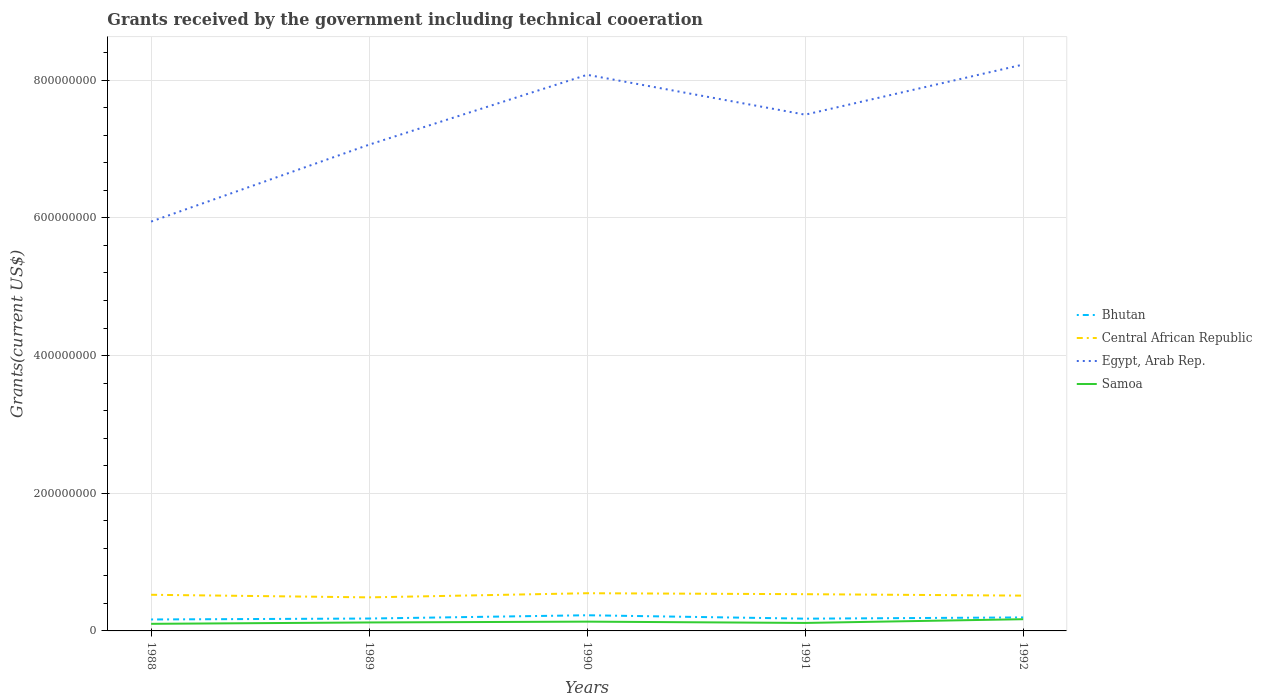How many different coloured lines are there?
Provide a succinct answer. 4. Does the line corresponding to Samoa intersect with the line corresponding to Egypt, Arab Rep.?
Offer a terse response. No. Across all years, what is the maximum total grants received by the government in Central African Republic?
Your answer should be compact. 4.87e+07. What is the total total grants received by the government in Central African Republic in the graph?
Your answer should be very brief. 1.23e+06. What is the difference between the highest and the second highest total grants received by the government in Samoa?
Your answer should be compact. 6.71e+06. What is the difference between the highest and the lowest total grants received by the government in Central African Republic?
Your answer should be compact. 3. Is the total grants received by the government in Bhutan strictly greater than the total grants received by the government in Samoa over the years?
Offer a terse response. No. How many lines are there?
Give a very brief answer. 4. Are the values on the major ticks of Y-axis written in scientific E-notation?
Your answer should be compact. No. Does the graph contain grids?
Ensure brevity in your answer.  Yes. What is the title of the graph?
Ensure brevity in your answer.  Grants received by the government including technical cooeration. Does "Nigeria" appear as one of the legend labels in the graph?
Make the answer very short. No. What is the label or title of the X-axis?
Ensure brevity in your answer.  Years. What is the label or title of the Y-axis?
Offer a very short reply. Grants(current US$). What is the Grants(current US$) in Bhutan in 1988?
Give a very brief answer. 1.66e+07. What is the Grants(current US$) in Central African Republic in 1988?
Give a very brief answer. 5.25e+07. What is the Grants(current US$) in Egypt, Arab Rep. in 1988?
Offer a very short reply. 5.95e+08. What is the Grants(current US$) in Samoa in 1988?
Ensure brevity in your answer.  1.03e+07. What is the Grants(current US$) of Bhutan in 1989?
Offer a terse response. 1.80e+07. What is the Grants(current US$) of Central African Republic in 1989?
Provide a succinct answer. 4.87e+07. What is the Grants(current US$) of Egypt, Arab Rep. in 1989?
Offer a very short reply. 7.06e+08. What is the Grants(current US$) in Samoa in 1989?
Your response must be concise. 1.23e+07. What is the Grants(current US$) in Bhutan in 1990?
Provide a short and direct response. 2.28e+07. What is the Grants(current US$) in Central African Republic in 1990?
Provide a succinct answer. 5.48e+07. What is the Grants(current US$) in Egypt, Arab Rep. in 1990?
Offer a terse response. 8.08e+08. What is the Grants(current US$) in Samoa in 1990?
Ensure brevity in your answer.  1.35e+07. What is the Grants(current US$) of Bhutan in 1991?
Give a very brief answer. 1.78e+07. What is the Grants(current US$) of Central African Republic in 1991?
Your response must be concise. 5.34e+07. What is the Grants(current US$) in Egypt, Arab Rep. in 1991?
Keep it short and to the point. 7.50e+08. What is the Grants(current US$) in Samoa in 1991?
Your response must be concise. 1.16e+07. What is the Grants(current US$) in Bhutan in 1992?
Your response must be concise. 1.96e+07. What is the Grants(current US$) in Central African Republic in 1992?
Your answer should be compact. 5.13e+07. What is the Grants(current US$) in Egypt, Arab Rep. in 1992?
Ensure brevity in your answer.  8.23e+08. What is the Grants(current US$) in Samoa in 1992?
Keep it short and to the point. 1.70e+07. Across all years, what is the maximum Grants(current US$) of Bhutan?
Give a very brief answer. 2.28e+07. Across all years, what is the maximum Grants(current US$) of Central African Republic?
Offer a very short reply. 5.48e+07. Across all years, what is the maximum Grants(current US$) in Egypt, Arab Rep.?
Make the answer very short. 8.23e+08. Across all years, what is the maximum Grants(current US$) of Samoa?
Provide a short and direct response. 1.70e+07. Across all years, what is the minimum Grants(current US$) in Bhutan?
Offer a terse response. 1.66e+07. Across all years, what is the minimum Grants(current US$) of Central African Republic?
Provide a succinct answer. 4.87e+07. Across all years, what is the minimum Grants(current US$) of Egypt, Arab Rep.?
Your answer should be very brief. 5.95e+08. Across all years, what is the minimum Grants(current US$) of Samoa?
Make the answer very short. 1.03e+07. What is the total Grants(current US$) of Bhutan in the graph?
Ensure brevity in your answer.  9.48e+07. What is the total Grants(current US$) in Central African Republic in the graph?
Your response must be concise. 2.61e+08. What is the total Grants(current US$) of Egypt, Arab Rep. in the graph?
Your answer should be compact. 3.68e+09. What is the total Grants(current US$) in Samoa in the graph?
Offer a very short reply. 6.47e+07. What is the difference between the Grants(current US$) of Bhutan in 1988 and that in 1989?
Your answer should be very brief. -1.36e+06. What is the difference between the Grants(current US$) in Central African Republic in 1988 and that in 1989?
Provide a succinct answer. 3.76e+06. What is the difference between the Grants(current US$) in Egypt, Arab Rep. in 1988 and that in 1989?
Keep it short and to the point. -1.12e+08. What is the difference between the Grants(current US$) of Samoa in 1988 and that in 1989?
Your response must be concise. -2.01e+06. What is the difference between the Grants(current US$) in Bhutan in 1988 and that in 1990?
Your answer should be compact. -6.13e+06. What is the difference between the Grants(current US$) in Central African Republic in 1988 and that in 1990?
Provide a short and direct response. -2.26e+06. What is the difference between the Grants(current US$) in Egypt, Arab Rep. in 1988 and that in 1990?
Provide a succinct answer. -2.13e+08. What is the difference between the Grants(current US$) of Samoa in 1988 and that in 1990?
Offer a terse response. -3.17e+06. What is the difference between the Grants(current US$) in Bhutan in 1988 and that in 1991?
Your answer should be compact. -1.16e+06. What is the difference between the Grants(current US$) in Central African Republic in 1988 and that in 1991?
Provide a short and direct response. -8.60e+05. What is the difference between the Grants(current US$) of Egypt, Arab Rep. in 1988 and that in 1991?
Your answer should be very brief. -1.55e+08. What is the difference between the Grants(current US$) of Samoa in 1988 and that in 1991?
Keep it short and to the point. -1.30e+06. What is the difference between the Grants(current US$) of Bhutan in 1988 and that in 1992?
Offer a very short reply. -2.97e+06. What is the difference between the Grants(current US$) of Central African Republic in 1988 and that in 1992?
Ensure brevity in your answer.  1.23e+06. What is the difference between the Grants(current US$) in Egypt, Arab Rep. in 1988 and that in 1992?
Make the answer very short. -2.28e+08. What is the difference between the Grants(current US$) in Samoa in 1988 and that in 1992?
Your answer should be very brief. -6.71e+06. What is the difference between the Grants(current US$) of Bhutan in 1989 and that in 1990?
Offer a very short reply. -4.77e+06. What is the difference between the Grants(current US$) in Central African Republic in 1989 and that in 1990?
Give a very brief answer. -6.02e+06. What is the difference between the Grants(current US$) in Egypt, Arab Rep. in 1989 and that in 1990?
Ensure brevity in your answer.  -1.02e+08. What is the difference between the Grants(current US$) in Samoa in 1989 and that in 1990?
Your answer should be very brief. -1.16e+06. What is the difference between the Grants(current US$) of Central African Republic in 1989 and that in 1991?
Give a very brief answer. -4.62e+06. What is the difference between the Grants(current US$) in Egypt, Arab Rep. in 1989 and that in 1991?
Provide a short and direct response. -4.36e+07. What is the difference between the Grants(current US$) of Samoa in 1989 and that in 1991?
Keep it short and to the point. 7.10e+05. What is the difference between the Grants(current US$) in Bhutan in 1989 and that in 1992?
Offer a terse response. -1.61e+06. What is the difference between the Grants(current US$) in Central African Republic in 1989 and that in 1992?
Make the answer very short. -2.53e+06. What is the difference between the Grants(current US$) in Egypt, Arab Rep. in 1989 and that in 1992?
Your answer should be compact. -1.16e+08. What is the difference between the Grants(current US$) of Samoa in 1989 and that in 1992?
Keep it short and to the point. -4.70e+06. What is the difference between the Grants(current US$) in Bhutan in 1990 and that in 1991?
Keep it short and to the point. 4.97e+06. What is the difference between the Grants(current US$) in Central African Republic in 1990 and that in 1991?
Your response must be concise. 1.40e+06. What is the difference between the Grants(current US$) in Egypt, Arab Rep. in 1990 and that in 1991?
Offer a very short reply. 5.79e+07. What is the difference between the Grants(current US$) of Samoa in 1990 and that in 1991?
Provide a succinct answer. 1.87e+06. What is the difference between the Grants(current US$) of Bhutan in 1990 and that in 1992?
Offer a terse response. 3.16e+06. What is the difference between the Grants(current US$) in Central African Republic in 1990 and that in 1992?
Your response must be concise. 3.49e+06. What is the difference between the Grants(current US$) in Egypt, Arab Rep. in 1990 and that in 1992?
Your answer should be compact. -1.49e+07. What is the difference between the Grants(current US$) of Samoa in 1990 and that in 1992?
Provide a succinct answer. -3.54e+06. What is the difference between the Grants(current US$) in Bhutan in 1991 and that in 1992?
Make the answer very short. -1.81e+06. What is the difference between the Grants(current US$) in Central African Republic in 1991 and that in 1992?
Provide a short and direct response. 2.09e+06. What is the difference between the Grants(current US$) of Egypt, Arab Rep. in 1991 and that in 1992?
Offer a very short reply. -7.28e+07. What is the difference between the Grants(current US$) in Samoa in 1991 and that in 1992?
Offer a terse response. -5.41e+06. What is the difference between the Grants(current US$) in Bhutan in 1988 and the Grants(current US$) in Central African Republic in 1989?
Your answer should be very brief. -3.21e+07. What is the difference between the Grants(current US$) of Bhutan in 1988 and the Grants(current US$) of Egypt, Arab Rep. in 1989?
Make the answer very short. -6.90e+08. What is the difference between the Grants(current US$) of Bhutan in 1988 and the Grants(current US$) of Samoa in 1989?
Ensure brevity in your answer.  4.33e+06. What is the difference between the Grants(current US$) of Central African Republic in 1988 and the Grants(current US$) of Egypt, Arab Rep. in 1989?
Provide a succinct answer. -6.54e+08. What is the difference between the Grants(current US$) of Central African Republic in 1988 and the Grants(current US$) of Samoa in 1989?
Make the answer very short. 4.02e+07. What is the difference between the Grants(current US$) of Egypt, Arab Rep. in 1988 and the Grants(current US$) of Samoa in 1989?
Your answer should be compact. 5.82e+08. What is the difference between the Grants(current US$) of Bhutan in 1988 and the Grants(current US$) of Central African Republic in 1990?
Offer a terse response. -3.81e+07. What is the difference between the Grants(current US$) of Bhutan in 1988 and the Grants(current US$) of Egypt, Arab Rep. in 1990?
Offer a very short reply. -7.91e+08. What is the difference between the Grants(current US$) of Bhutan in 1988 and the Grants(current US$) of Samoa in 1990?
Give a very brief answer. 3.17e+06. What is the difference between the Grants(current US$) in Central African Republic in 1988 and the Grants(current US$) in Egypt, Arab Rep. in 1990?
Ensure brevity in your answer.  -7.55e+08. What is the difference between the Grants(current US$) of Central African Republic in 1988 and the Grants(current US$) of Samoa in 1990?
Ensure brevity in your answer.  3.90e+07. What is the difference between the Grants(current US$) in Egypt, Arab Rep. in 1988 and the Grants(current US$) in Samoa in 1990?
Provide a succinct answer. 5.81e+08. What is the difference between the Grants(current US$) of Bhutan in 1988 and the Grants(current US$) of Central African Republic in 1991?
Your answer should be very brief. -3.67e+07. What is the difference between the Grants(current US$) in Bhutan in 1988 and the Grants(current US$) in Egypt, Arab Rep. in 1991?
Provide a short and direct response. -7.33e+08. What is the difference between the Grants(current US$) of Bhutan in 1988 and the Grants(current US$) of Samoa in 1991?
Ensure brevity in your answer.  5.04e+06. What is the difference between the Grants(current US$) in Central African Republic in 1988 and the Grants(current US$) in Egypt, Arab Rep. in 1991?
Your answer should be compact. -6.97e+08. What is the difference between the Grants(current US$) in Central African Republic in 1988 and the Grants(current US$) in Samoa in 1991?
Provide a succinct answer. 4.09e+07. What is the difference between the Grants(current US$) of Egypt, Arab Rep. in 1988 and the Grants(current US$) of Samoa in 1991?
Your response must be concise. 5.83e+08. What is the difference between the Grants(current US$) of Bhutan in 1988 and the Grants(current US$) of Central African Republic in 1992?
Your answer should be compact. -3.46e+07. What is the difference between the Grants(current US$) of Bhutan in 1988 and the Grants(current US$) of Egypt, Arab Rep. in 1992?
Ensure brevity in your answer.  -8.06e+08. What is the difference between the Grants(current US$) of Bhutan in 1988 and the Grants(current US$) of Samoa in 1992?
Offer a terse response. -3.70e+05. What is the difference between the Grants(current US$) of Central African Republic in 1988 and the Grants(current US$) of Egypt, Arab Rep. in 1992?
Ensure brevity in your answer.  -7.70e+08. What is the difference between the Grants(current US$) of Central African Republic in 1988 and the Grants(current US$) of Samoa in 1992?
Offer a very short reply. 3.55e+07. What is the difference between the Grants(current US$) in Egypt, Arab Rep. in 1988 and the Grants(current US$) in Samoa in 1992?
Your response must be concise. 5.78e+08. What is the difference between the Grants(current US$) of Bhutan in 1989 and the Grants(current US$) of Central African Republic in 1990?
Provide a short and direct response. -3.68e+07. What is the difference between the Grants(current US$) of Bhutan in 1989 and the Grants(current US$) of Egypt, Arab Rep. in 1990?
Provide a short and direct response. -7.90e+08. What is the difference between the Grants(current US$) of Bhutan in 1989 and the Grants(current US$) of Samoa in 1990?
Ensure brevity in your answer.  4.53e+06. What is the difference between the Grants(current US$) in Central African Republic in 1989 and the Grants(current US$) in Egypt, Arab Rep. in 1990?
Give a very brief answer. -7.59e+08. What is the difference between the Grants(current US$) of Central African Republic in 1989 and the Grants(current US$) of Samoa in 1990?
Your answer should be very brief. 3.53e+07. What is the difference between the Grants(current US$) of Egypt, Arab Rep. in 1989 and the Grants(current US$) of Samoa in 1990?
Make the answer very short. 6.93e+08. What is the difference between the Grants(current US$) in Bhutan in 1989 and the Grants(current US$) in Central African Republic in 1991?
Ensure brevity in your answer.  -3.54e+07. What is the difference between the Grants(current US$) of Bhutan in 1989 and the Grants(current US$) of Egypt, Arab Rep. in 1991?
Provide a short and direct response. -7.32e+08. What is the difference between the Grants(current US$) of Bhutan in 1989 and the Grants(current US$) of Samoa in 1991?
Your answer should be very brief. 6.40e+06. What is the difference between the Grants(current US$) in Central African Republic in 1989 and the Grants(current US$) in Egypt, Arab Rep. in 1991?
Offer a terse response. -7.01e+08. What is the difference between the Grants(current US$) in Central African Republic in 1989 and the Grants(current US$) in Samoa in 1991?
Make the answer very short. 3.71e+07. What is the difference between the Grants(current US$) in Egypt, Arab Rep. in 1989 and the Grants(current US$) in Samoa in 1991?
Give a very brief answer. 6.95e+08. What is the difference between the Grants(current US$) in Bhutan in 1989 and the Grants(current US$) in Central African Republic in 1992?
Give a very brief answer. -3.33e+07. What is the difference between the Grants(current US$) of Bhutan in 1989 and the Grants(current US$) of Egypt, Arab Rep. in 1992?
Your response must be concise. -8.05e+08. What is the difference between the Grants(current US$) in Bhutan in 1989 and the Grants(current US$) in Samoa in 1992?
Your answer should be very brief. 9.90e+05. What is the difference between the Grants(current US$) of Central African Republic in 1989 and the Grants(current US$) of Egypt, Arab Rep. in 1992?
Keep it short and to the point. -7.74e+08. What is the difference between the Grants(current US$) in Central African Republic in 1989 and the Grants(current US$) in Samoa in 1992?
Your answer should be very brief. 3.17e+07. What is the difference between the Grants(current US$) in Egypt, Arab Rep. in 1989 and the Grants(current US$) in Samoa in 1992?
Ensure brevity in your answer.  6.89e+08. What is the difference between the Grants(current US$) of Bhutan in 1990 and the Grants(current US$) of Central African Republic in 1991?
Provide a succinct answer. -3.06e+07. What is the difference between the Grants(current US$) in Bhutan in 1990 and the Grants(current US$) in Egypt, Arab Rep. in 1991?
Your response must be concise. -7.27e+08. What is the difference between the Grants(current US$) in Bhutan in 1990 and the Grants(current US$) in Samoa in 1991?
Make the answer very short. 1.12e+07. What is the difference between the Grants(current US$) in Central African Republic in 1990 and the Grants(current US$) in Egypt, Arab Rep. in 1991?
Offer a very short reply. -6.95e+08. What is the difference between the Grants(current US$) in Central African Republic in 1990 and the Grants(current US$) in Samoa in 1991?
Your answer should be very brief. 4.32e+07. What is the difference between the Grants(current US$) of Egypt, Arab Rep. in 1990 and the Grants(current US$) of Samoa in 1991?
Keep it short and to the point. 7.96e+08. What is the difference between the Grants(current US$) of Bhutan in 1990 and the Grants(current US$) of Central African Republic in 1992?
Provide a short and direct response. -2.85e+07. What is the difference between the Grants(current US$) in Bhutan in 1990 and the Grants(current US$) in Egypt, Arab Rep. in 1992?
Your answer should be very brief. -8.00e+08. What is the difference between the Grants(current US$) in Bhutan in 1990 and the Grants(current US$) in Samoa in 1992?
Offer a terse response. 5.76e+06. What is the difference between the Grants(current US$) of Central African Republic in 1990 and the Grants(current US$) of Egypt, Arab Rep. in 1992?
Offer a very short reply. -7.68e+08. What is the difference between the Grants(current US$) of Central African Republic in 1990 and the Grants(current US$) of Samoa in 1992?
Offer a terse response. 3.78e+07. What is the difference between the Grants(current US$) in Egypt, Arab Rep. in 1990 and the Grants(current US$) in Samoa in 1992?
Offer a very short reply. 7.91e+08. What is the difference between the Grants(current US$) of Bhutan in 1991 and the Grants(current US$) of Central African Republic in 1992?
Provide a succinct answer. -3.35e+07. What is the difference between the Grants(current US$) in Bhutan in 1991 and the Grants(current US$) in Egypt, Arab Rep. in 1992?
Make the answer very short. -8.05e+08. What is the difference between the Grants(current US$) of Bhutan in 1991 and the Grants(current US$) of Samoa in 1992?
Provide a succinct answer. 7.90e+05. What is the difference between the Grants(current US$) in Central African Republic in 1991 and the Grants(current US$) in Egypt, Arab Rep. in 1992?
Offer a very short reply. -7.69e+08. What is the difference between the Grants(current US$) in Central African Republic in 1991 and the Grants(current US$) in Samoa in 1992?
Keep it short and to the point. 3.64e+07. What is the difference between the Grants(current US$) in Egypt, Arab Rep. in 1991 and the Grants(current US$) in Samoa in 1992?
Offer a very short reply. 7.33e+08. What is the average Grants(current US$) of Bhutan per year?
Provide a short and direct response. 1.90e+07. What is the average Grants(current US$) in Central African Republic per year?
Keep it short and to the point. 5.21e+07. What is the average Grants(current US$) of Egypt, Arab Rep. per year?
Make the answer very short. 7.36e+08. What is the average Grants(current US$) in Samoa per year?
Your response must be concise. 1.29e+07. In the year 1988, what is the difference between the Grants(current US$) of Bhutan and Grants(current US$) of Central African Republic?
Offer a terse response. -3.59e+07. In the year 1988, what is the difference between the Grants(current US$) in Bhutan and Grants(current US$) in Egypt, Arab Rep.?
Provide a short and direct response. -5.78e+08. In the year 1988, what is the difference between the Grants(current US$) in Bhutan and Grants(current US$) in Samoa?
Offer a terse response. 6.34e+06. In the year 1988, what is the difference between the Grants(current US$) of Central African Republic and Grants(current US$) of Egypt, Arab Rep.?
Ensure brevity in your answer.  -5.42e+08. In the year 1988, what is the difference between the Grants(current US$) in Central African Republic and Grants(current US$) in Samoa?
Offer a very short reply. 4.22e+07. In the year 1988, what is the difference between the Grants(current US$) of Egypt, Arab Rep. and Grants(current US$) of Samoa?
Provide a succinct answer. 5.84e+08. In the year 1989, what is the difference between the Grants(current US$) in Bhutan and Grants(current US$) in Central African Republic?
Offer a very short reply. -3.07e+07. In the year 1989, what is the difference between the Grants(current US$) of Bhutan and Grants(current US$) of Egypt, Arab Rep.?
Provide a short and direct response. -6.88e+08. In the year 1989, what is the difference between the Grants(current US$) of Bhutan and Grants(current US$) of Samoa?
Your answer should be very brief. 5.69e+06. In the year 1989, what is the difference between the Grants(current US$) of Central African Republic and Grants(current US$) of Egypt, Arab Rep.?
Your response must be concise. -6.58e+08. In the year 1989, what is the difference between the Grants(current US$) in Central African Republic and Grants(current US$) in Samoa?
Offer a very short reply. 3.64e+07. In the year 1989, what is the difference between the Grants(current US$) of Egypt, Arab Rep. and Grants(current US$) of Samoa?
Offer a very short reply. 6.94e+08. In the year 1990, what is the difference between the Grants(current US$) in Bhutan and Grants(current US$) in Central African Republic?
Provide a succinct answer. -3.20e+07. In the year 1990, what is the difference between the Grants(current US$) in Bhutan and Grants(current US$) in Egypt, Arab Rep.?
Your answer should be compact. -7.85e+08. In the year 1990, what is the difference between the Grants(current US$) in Bhutan and Grants(current US$) in Samoa?
Provide a short and direct response. 9.30e+06. In the year 1990, what is the difference between the Grants(current US$) in Central African Republic and Grants(current US$) in Egypt, Arab Rep.?
Your answer should be compact. -7.53e+08. In the year 1990, what is the difference between the Grants(current US$) of Central African Republic and Grants(current US$) of Samoa?
Your response must be concise. 4.13e+07. In the year 1990, what is the difference between the Grants(current US$) in Egypt, Arab Rep. and Grants(current US$) in Samoa?
Offer a terse response. 7.94e+08. In the year 1991, what is the difference between the Grants(current US$) in Bhutan and Grants(current US$) in Central African Republic?
Keep it short and to the point. -3.56e+07. In the year 1991, what is the difference between the Grants(current US$) in Bhutan and Grants(current US$) in Egypt, Arab Rep.?
Offer a very short reply. -7.32e+08. In the year 1991, what is the difference between the Grants(current US$) in Bhutan and Grants(current US$) in Samoa?
Offer a very short reply. 6.20e+06. In the year 1991, what is the difference between the Grants(current US$) of Central African Republic and Grants(current US$) of Egypt, Arab Rep.?
Your answer should be compact. -6.97e+08. In the year 1991, what is the difference between the Grants(current US$) of Central African Republic and Grants(current US$) of Samoa?
Provide a succinct answer. 4.18e+07. In the year 1991, what is the difference between the Grants(current US$) in Egypt, Arab Rep. and Grants(current US$) in Samoa?
Make the answer very short. 7.38e+08. In the year 1992, what is the difference between the Grants(current US$) in Bhutan and Grants(current US$) in Central African Republic?
Ensure brevity in your answer.  -3.17e+07. In the year 1992, what is the difference between the Grants(current US$) in Bhutan and Grants(current US$) in Egypt, Arab Rep.?
Offer a terse response. -8.03e+08. In the year 1992, what is the difference between the Grants(current US$) in Bhutan and Grants(current US$) in Samoa?
Give a very brief answer. 2.60e+06. In the year 1992, what is the difference between the Grants(current US$) in Central African Republic and Grants(current US$) in Egypt, Arab Rep.?
Keep it short and to the point. -7.71e+08. In the year 1992, what is the difference between the Grants(current US$) in Central African Republic and Grants(current US$) in Samoa?
Offer a terse response. 3.43e+07. In the year 1992, what is the difference between the Grants(current US$) in Egypt, Arab Rep. and Grants(current US$) in Samoa?
Ensure brevity in your answer.  8.06e+08. What is the ratio of the Grants(current US$) in Bhutan in 1988 to that in 1989?
Offer a terse response. 0.92. What is the ratio of the Grants(current US$) in Central African Republic in 1988 to that in 1989?
Make the answer very short. 1.08. What is the ratio of the Grants(current US$) in Egypt, Arab Rep. in 1988 to that in 1989?
Offer a very short reply. 0.84. What is the ratio of the Grants(current US$) of Samoa in 1988 to that in 1989?
Provide a short and direct response. 0.84. What is the ratio of the Grants(current US$) of Bhutan in 1988 to that in 1990?
Your answer should be compact. 0.73. What is the ratio of the Grants(current US$) of Central African Republic in 1988 to that in 1990?
Your answer should be very brief. 0.96. What is the ratio of the Grants(current US$) in Egypt, Arab Rep. in 1988 to that in 1990?
Your answer should be compact. 0.74. What is the ratio of the Grants(current US$) in Samoa in 1988 to that in 1990?
Offer a very short reply. 0.76. What is the ratio of the Grants(current US$) of Bhutan in 1988 to that in 1991?
Your answer should be very brief. 0.93. What is the ratio of the Grants(current US$) of Central African Republic in 1988 to that in 1991?
Offer a very short reply. 0.98. What is the ratio of the Grants(current US$) in Egypt, Arab Rep. in 1988 to that in 1991?
Your response must be concise. 0.79. What is the ratio of the Grants(current US$) in Samoa in 1988 to that in 1991?
Make the answer very short. 0.89. What is the ratio of the Grants(current US$) of Bhutan in 1988 to that in 1992?
Provide a short and direct response. 0.85. What is the ratio of the Grants(current US$) of Egypt, Arab Rep. in 1988 to that in 1992?
Ensure brevity in your answer.  0.72. What is the ratio of the Grants(current US$) of Samoa in 1988 to that in 1992?
Your answer should be compact. 0.61. What is the ratio of the Grants(current US$) of Bhutan in 1989 to that in 1990?
Your answer should be compact. 0.79. What is the ratio of the Grants(current US$) in Central African Republic in 1989 to that in 1990?
Your response must be concise. 0.89. What is the ratio of the Grants(current US$) in Egypt, Arab Rep. in 1989 to that in 1990?
Your answer should be very brief. 0.87. What is the ratio of the Grants(current US$) of Samoa in 1989 to that in 1990?
Offer a terse response. 0.91. What is the ratio of the Grants(current US$) of Bhutan in 1989 to that in 1991?
Give a very brief answer. 1.01. What is the ratio of the Grants(current US$) of Central African Republic in 1989 to that in 1991?
Offer a very short reply. 0.91. What is the ratio of the Grants(current US$) in Egypt, Arab Rep. in 1989 to that in 1991?
Keep it short and to the point. 0.94. What is the ratio of the Grants(current US$) of Samoa in 1989 to that in 1991?
Your answer should be compact. 1.06. What is the ratio of the Grants(current US$) in Bhutan in 1989 to that in 1992?
Your response must be concise. 0.92. What is the ratio of the Grants(current US$) in Central African Republic in 1989 to that in 1992?
Keep it short and to the point. 0.95. What is the ratio of the Grants(current US$) of Egypt, Arab Rep. in 1989 to that in 1992?
Your answer should be compact. 0.86. What is the ratio of the Grants(current US$) in Samoa in 1989 to that in 1992?
Provide a succinct answer. 0.72. What is the ratio of the Grants(current US$) of Bhutan in 1990 to that in 1991?
Your response must be concise. 1.28. What is the ratio of the Grants(current US$) of Central African Republic in 1990 to that in 1991?
Your response must be concise. 1.03. What is the ratio of the Grants(current US$) of Egypt, Arab Rep. in 1990 to that in 1991?
Give a very brief answer. 1.08. What is the ratio of the Grants(current US$) in Samoa in 1990 to that in 1991?
Provide a short and direct response. 1.16. What is the ratio of the Grants(current US$) in Bhutan in 1990 to that in 1992?
Your response must be concise. 1.16. What is the ratio of the Grants(current US$) of Central African Republic in 1990 to that in 1992?
Give a very brief answer. 1.07. What is the ratio of the Grants(current US$) of Egypt, Arab Rep. in 1990 to that in 1992?
Give a very brief answer. 0.98. What is the ratio of the Grants(current US$) of Samoa in 1990 to that in 1992?
Your answer should be compact. 0.79. What is the ratio of the Grants(current US$) in Bhutan in 1991 to that in 1992?
Your answer should be compact. 0.91. What is the ratio of the Grants(current US$) of Central African Republic in 1991 to that in 1992?
Offer a terse response. 1.04. What is the ratio of the Grants(current US$) in Egypt, Arab Rep. in 1991 to that in 1992?
Provide a succinct answer. 0.91. What is the ratio of the Grants(current US$) in Samoa in 1991 to that in 1992?
Offer a terse response. 0.68. What is the difference between the highest and the second highest Grants(current US$) in Bhutan?
Keep it short and to the point. 3.16e+06. What is the difference between the highest and the second highest Grants(current US$) of Central African Republic?
Offer a very short reply. 1.40e+06. What is the difference between the highest and the second highest Grants(current US$) of Egypt, Arab Rep.?
Keep it short and to the point. 1.49e+07. What is the difference between the highest and the second highest Grants(current US$) in Samoa?
Your answer should be very brief. 3.54e+06. What is the difference between the highest and the lowest Grants(current US$) in Bhutan?
Give a very brief answer. 6.13e+06. What is the difference between the highest and the lowest Grants(current US$) in Central African Republic?
Provide a succinct answer. 6.02e+06. What is the difference between the highest and the lowest Grants(current US$) in Egypt, Arab Rep.?
Offer a very short reply. 2.28e+08. What is the difference between the highest and the lowest Grants(current US$) of Samoa?
Offer a terse response. 6.71e+06. 